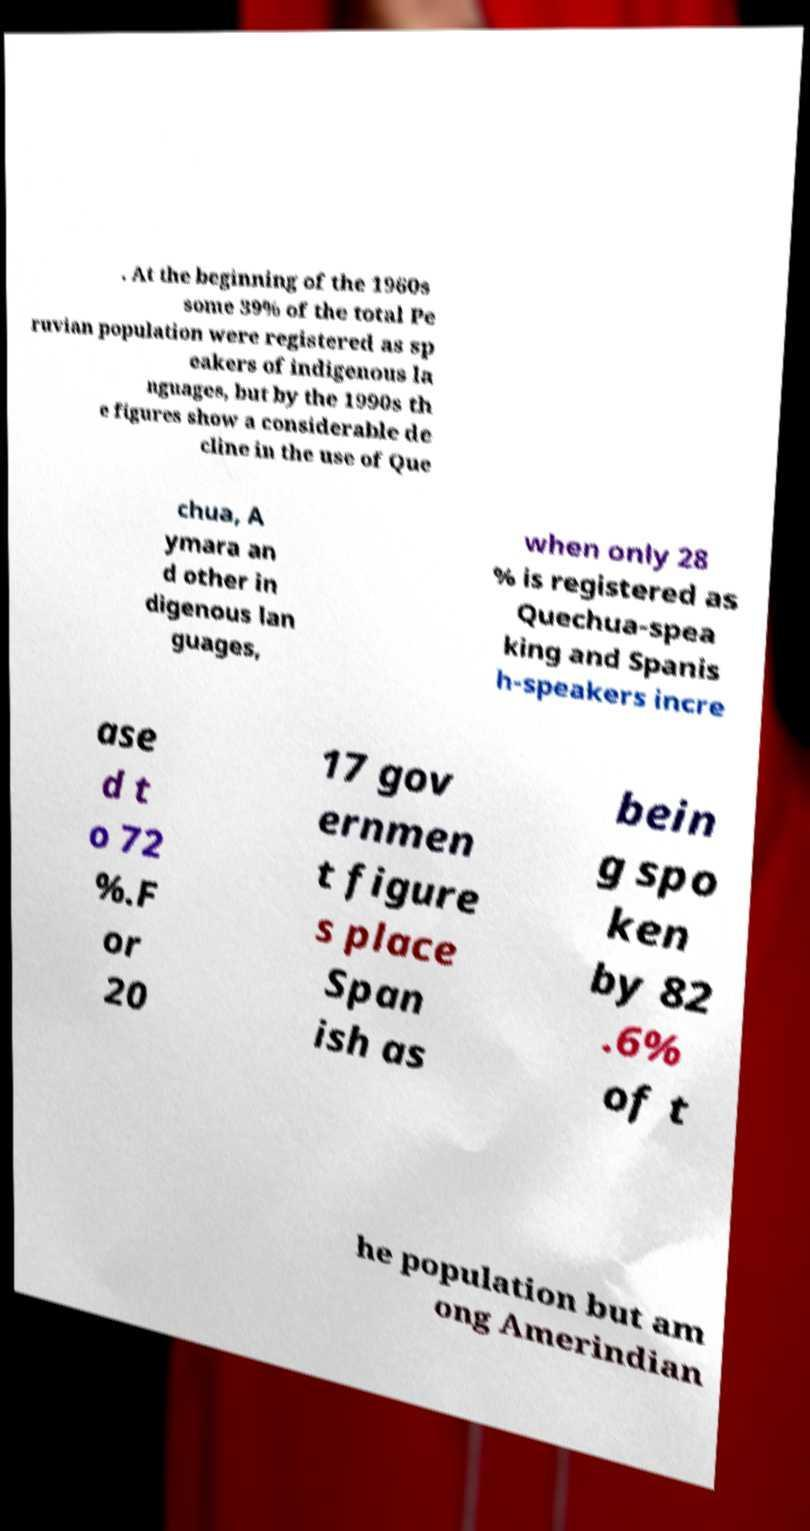I need the written content from this picture converted into text. Can you do that? . At the beginning of the 1960s some 39% of the total Pe ruvian population were registered as sp eakers of indigenous la nguages, but by the 1990s th e figures show a considerable de cline in the use of Que chua, A ymara an d other in digenous lan guages, when only 28 % is registered as Quechua-spea king and Spanis h-speakers incre ase d t o 72 %.F or 20 17 gov ernmen t figure s place Span ish as bein g spo ken by 82 .6% of t he population but am ong Amerindian 